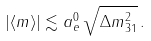Convert formula to latex. <formula><loc_0><loc_0><loc_500><loc_500>| \langle { m } \rangle | \lesssim a _ { e } ^ { 0 } \, \sqrt { \Delta { m } ^ { 2 } _ { 3 1 } } \, .</formula> 